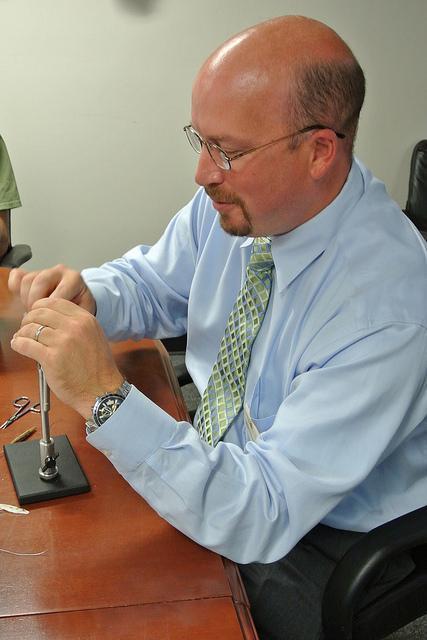How many men are there?
Give a very brief answer. 1. 